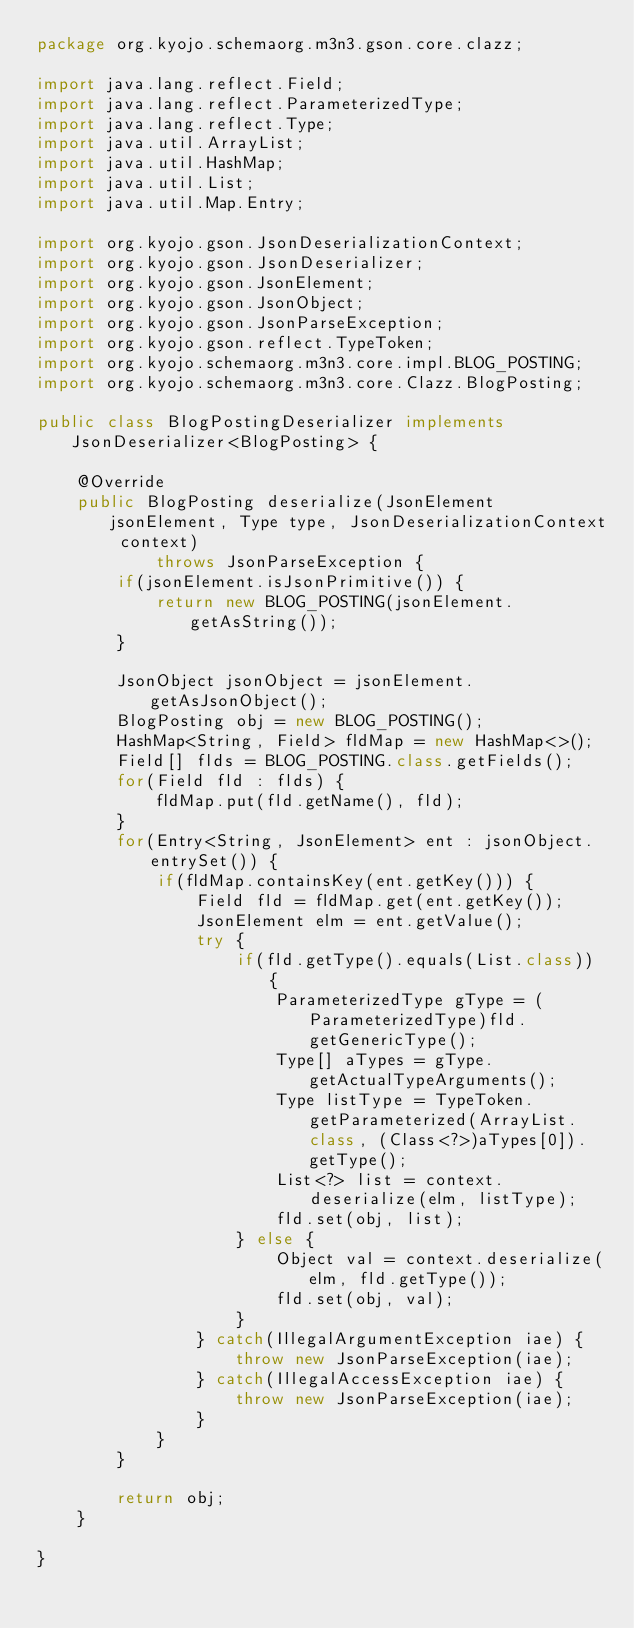<code> <loc_0><loc_0><loc_500><loc_500><_Java_>package org.kyojo.schemaorg.m3n3.gson.core.clazz;

import java.lang.reflect.Field;
import java.lang.reflect.ParameterizedType;
import java.lang.reflect.Type;
import java.util.ArrayList;
import java.util.HashMap;
import java.util.List;
import java.util.Map.Entry;

import org.kyojo.gson.JsonDeserializationContext;
import org.kyojo.gson.JsonDeserializer;
import org.kyojo.gson.JsonElement;
import org.kyojo.gson.JsonObject;
import org.kyojo.gson.JsonParseException;
import org.kyojo.gson.reflect.TypeToken;
import org.kyojo.schemaorg.m3n3.core.impl.BLOG_POSTING;
import org.kyojo.schemaorg.m3n3.core.Clazz.BlogPosting;

public class BlogPostingDeserializer implements JsonDeserializer<BlogPosting> {

	@Override
	public BlogPosting deserialize(JsonElement jsonElement, Type type, JsonDeserializationContext context)
			throws JsonParseException {
		if(jsonElement.isJsonPrimitive()) {
			return new BLOG_POSTING(jsonElement.getAsString());
		}

		JsonObject jsonObject = jsonElement.getAsJsonObject();
		BlogPosting obj = new BLOG_POSTING();
		HashMap<String, Field> fldMap = new HashMap<>();
		Field[] flds = BLOG_POSTING.class.getFields();
		for(Field fld : flds) {
			fldMap.put(fld.getName(), fld);
		}
		for(Entry<String, JsonElement> ent : jsonObject.entrySet()) {
			if(fldMap.containsKey(ent.getKey())) {
				Field fld = fldMap.get(ent.getKey());
				JsonElement elm = ent.getValue();
				try {
					if(fld.getType().equals(List.class)) {
						ParameterizedType gType = (ParameterizedType)fld.getGenericType();
						Type[] aTypes = gType.getActualTypeArguments();
						Type listType = TypeToken.getParameterized(ArrayList.class, (Class<?>)aTypes[0]).getType();
						List<?> list = context.deserialize(elm, listType);
						fld.set(obj, list);
					} else {
						Object val = context.deserialize(elm, fld.getType());
						fld.set(obj, val);
					}
				} catch(IllegalArgumentException iae) {
					throw new JsonParseException(iae);
				} catch(IllegalAccessException iae) {
					throw new JsonParseException(iae);
				}
			}
		}

		return obj;
	}

}
</code> 